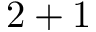<formula> <loc_0><loc_0><loc_500><loc_500>2 + 1</formula> 